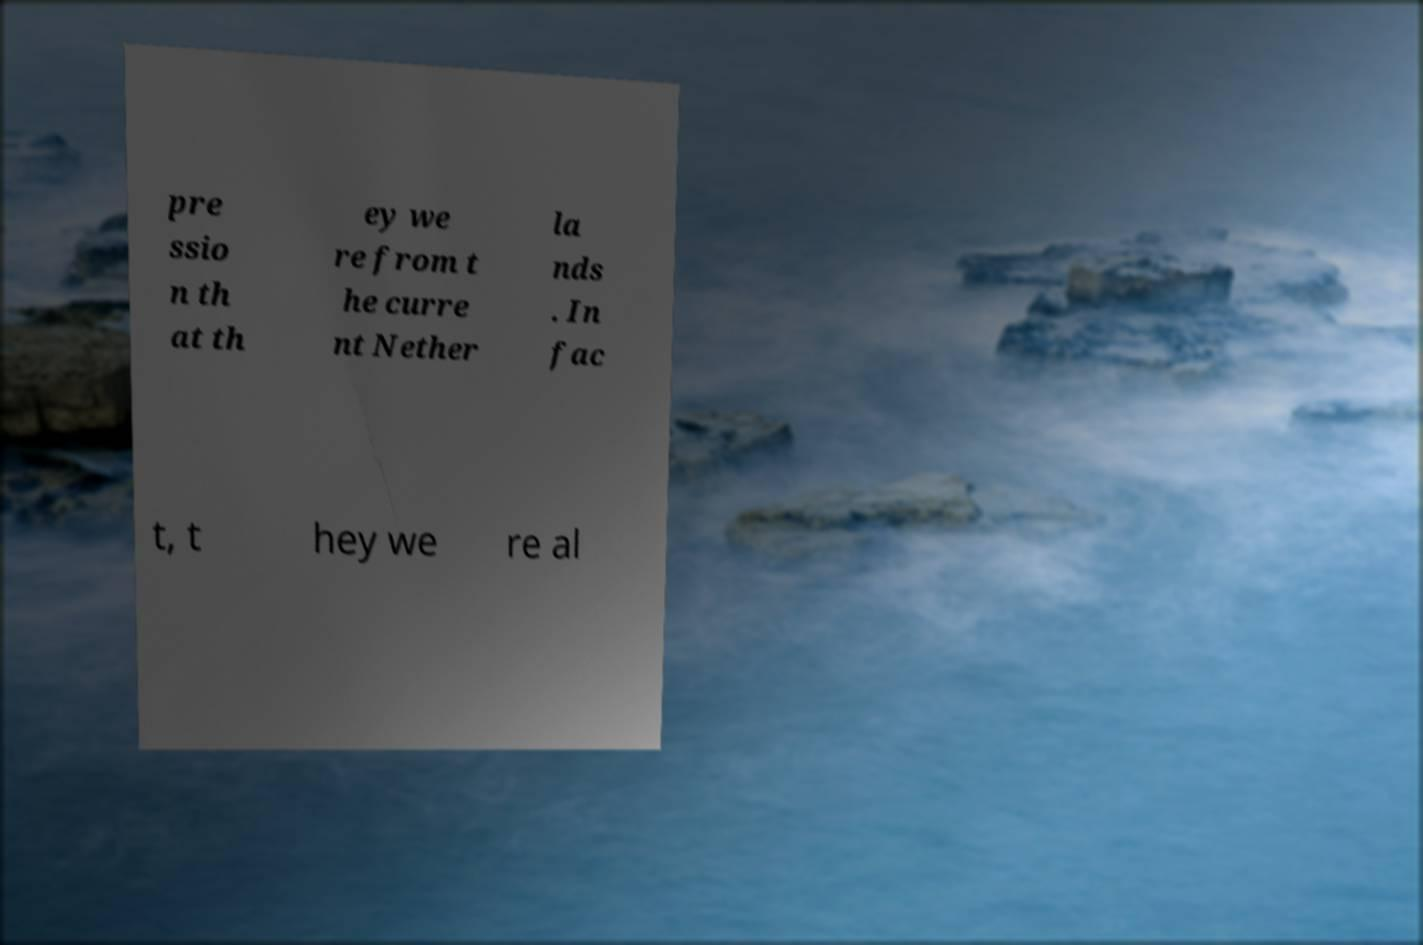Please read and relay the text visible in this image. What does it say? pre ssio n th at th ey we re from t he curre nt Nether la nds . In fac t, t hey we re al 